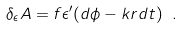<formula> <loc_0><loc_0><loc_500><loc_500>\delta _ { \epsilon } A = f \epsilon ^ { \prime } ( d \phi - k r d t ) \ .</formula> 